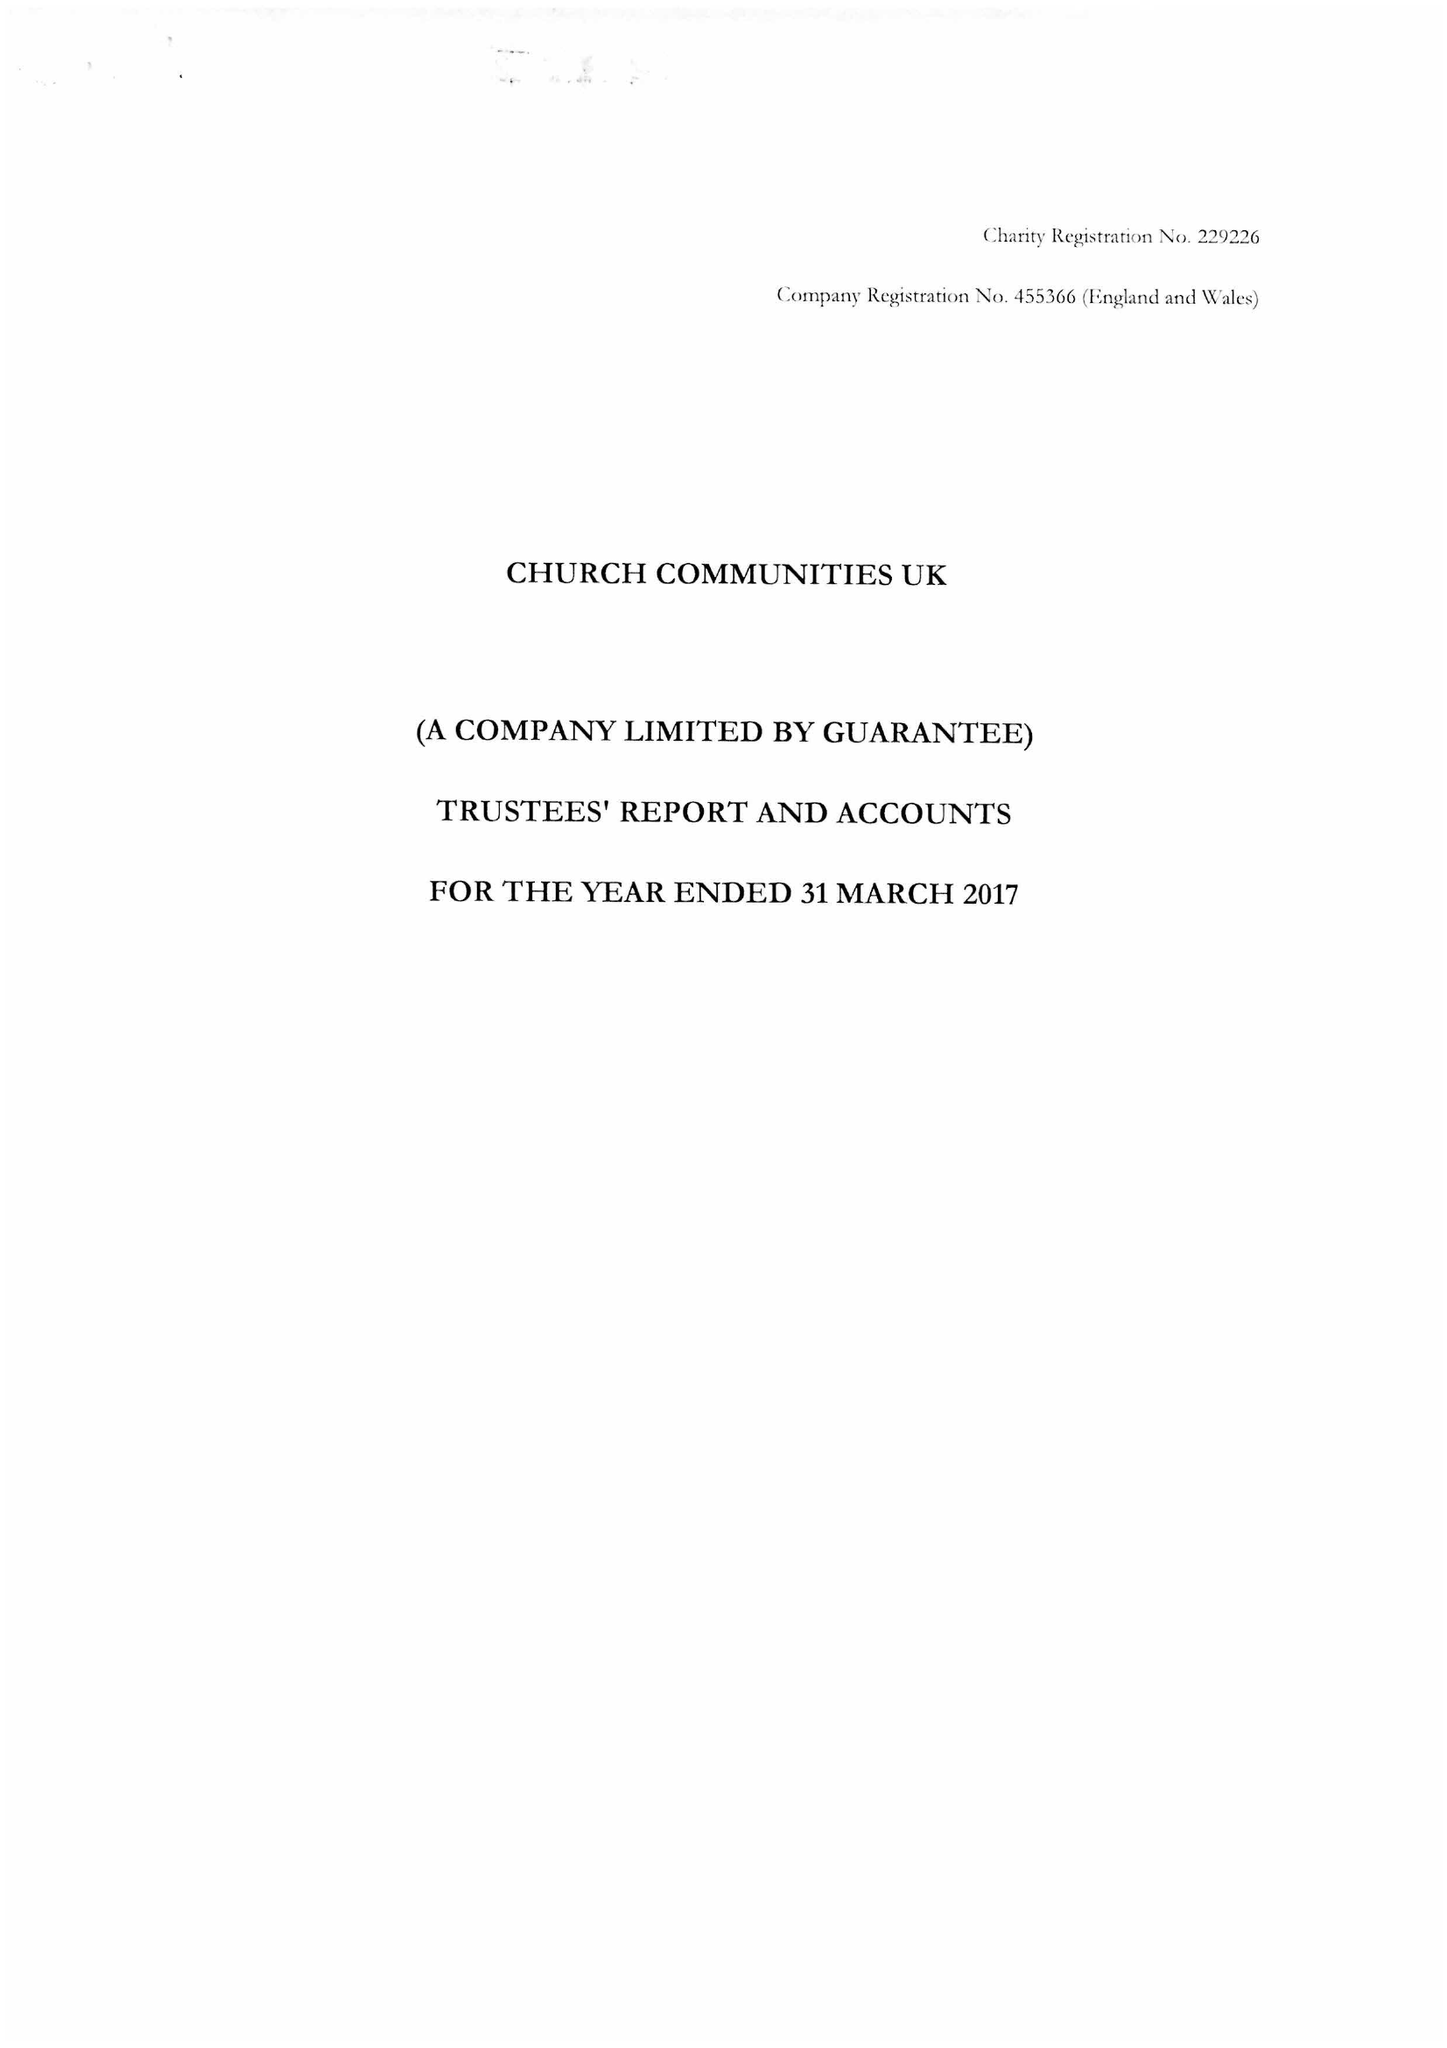What is the value for the spending_annually_in_british_pounds?
Answer the question using a single word or phrase. 19237682.00 